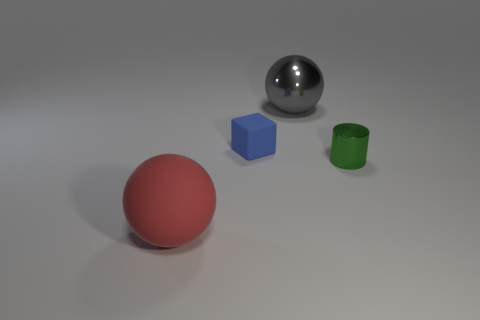What number of other objects are there of the same material as the cube?
Your response must be concise. 1. Are the sphere that is in front of the large metal sphere and the block made of the same material?
Your answer should be compact. Yes. The small rubber object has what shape?
Offer a terse response. Cube. Are there more big balls that are to the right of the blue object than large purple rubber blocks?
Provide a succinct answer. Yes. Is there anything else that is the same shape as the tiny green metal object?
Your answer should be compact. No. The other object that is the same shape as the red thing is what color?
Your answer should be compact. Gray. What is the shape of the tiny object to the right of the blue matte thing?
Your response must be concise. Cylinder. Are there any big things behind the small rubber thing?
Offer a terse response. Yes. The large object that is made of the same material as the small blue thing is what color?
Provide a short and direct response. Red. How many cubes are purple things or red matte things?
Your answer should be very brief. 0. 